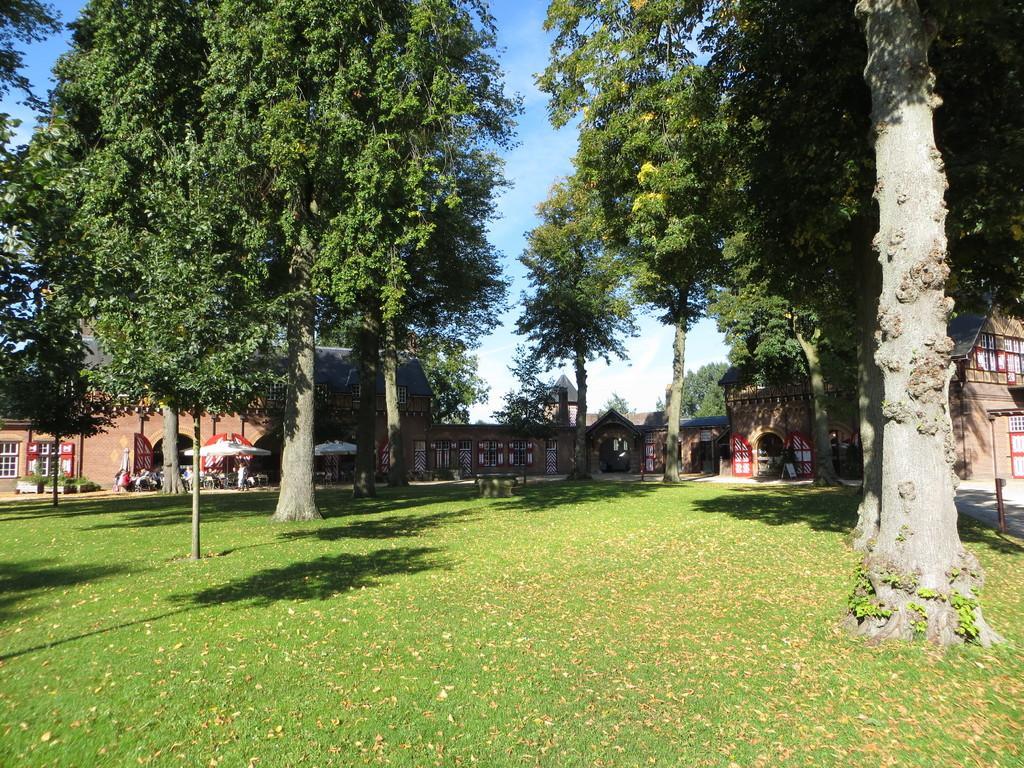Could you give a brief overview of what you see in this image? This is an outside view. At the bottom, I can see the grass. In the background there are some buildings and trees. At the top, I can see the sky. 